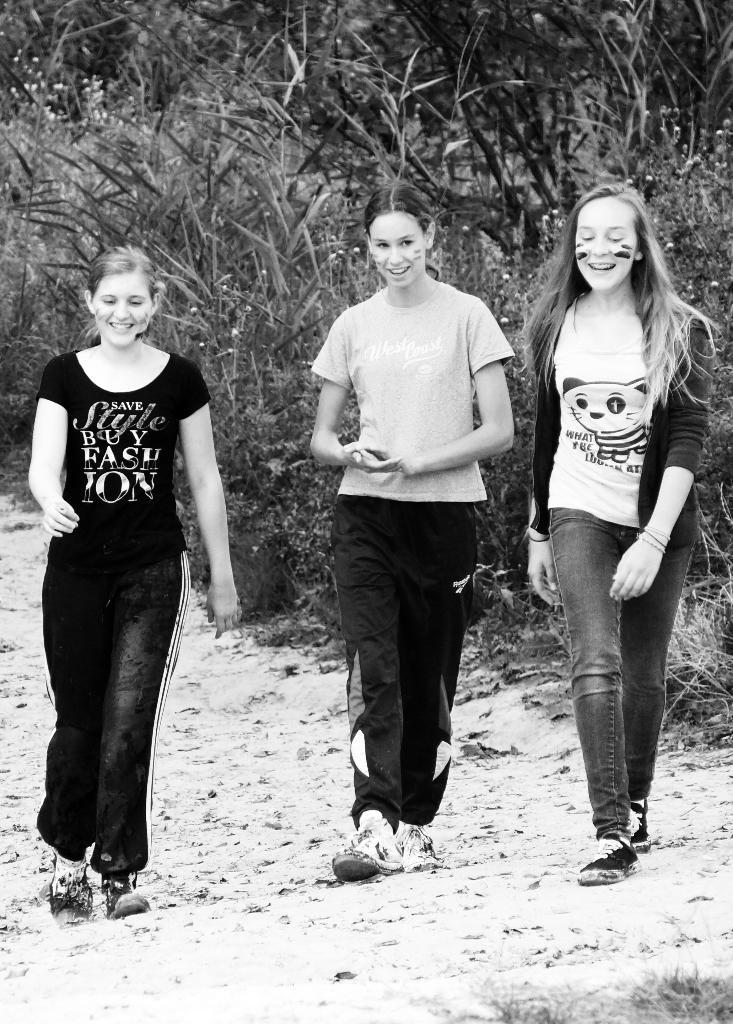What is the color scheme of the image? The image is black and white. What can be seen in the image? There are people in the image. What is visible in the background of the image? There are trees in the background of the image. What is visible at the bottom of the image? The ground is visible at the bottom of the image. How many quills are visible in the image? There are no quills present in the image. Can you tell me how many jellyfish are swimming in the background of the image? There are no jellyfish present in the image; it features trees in the background. 